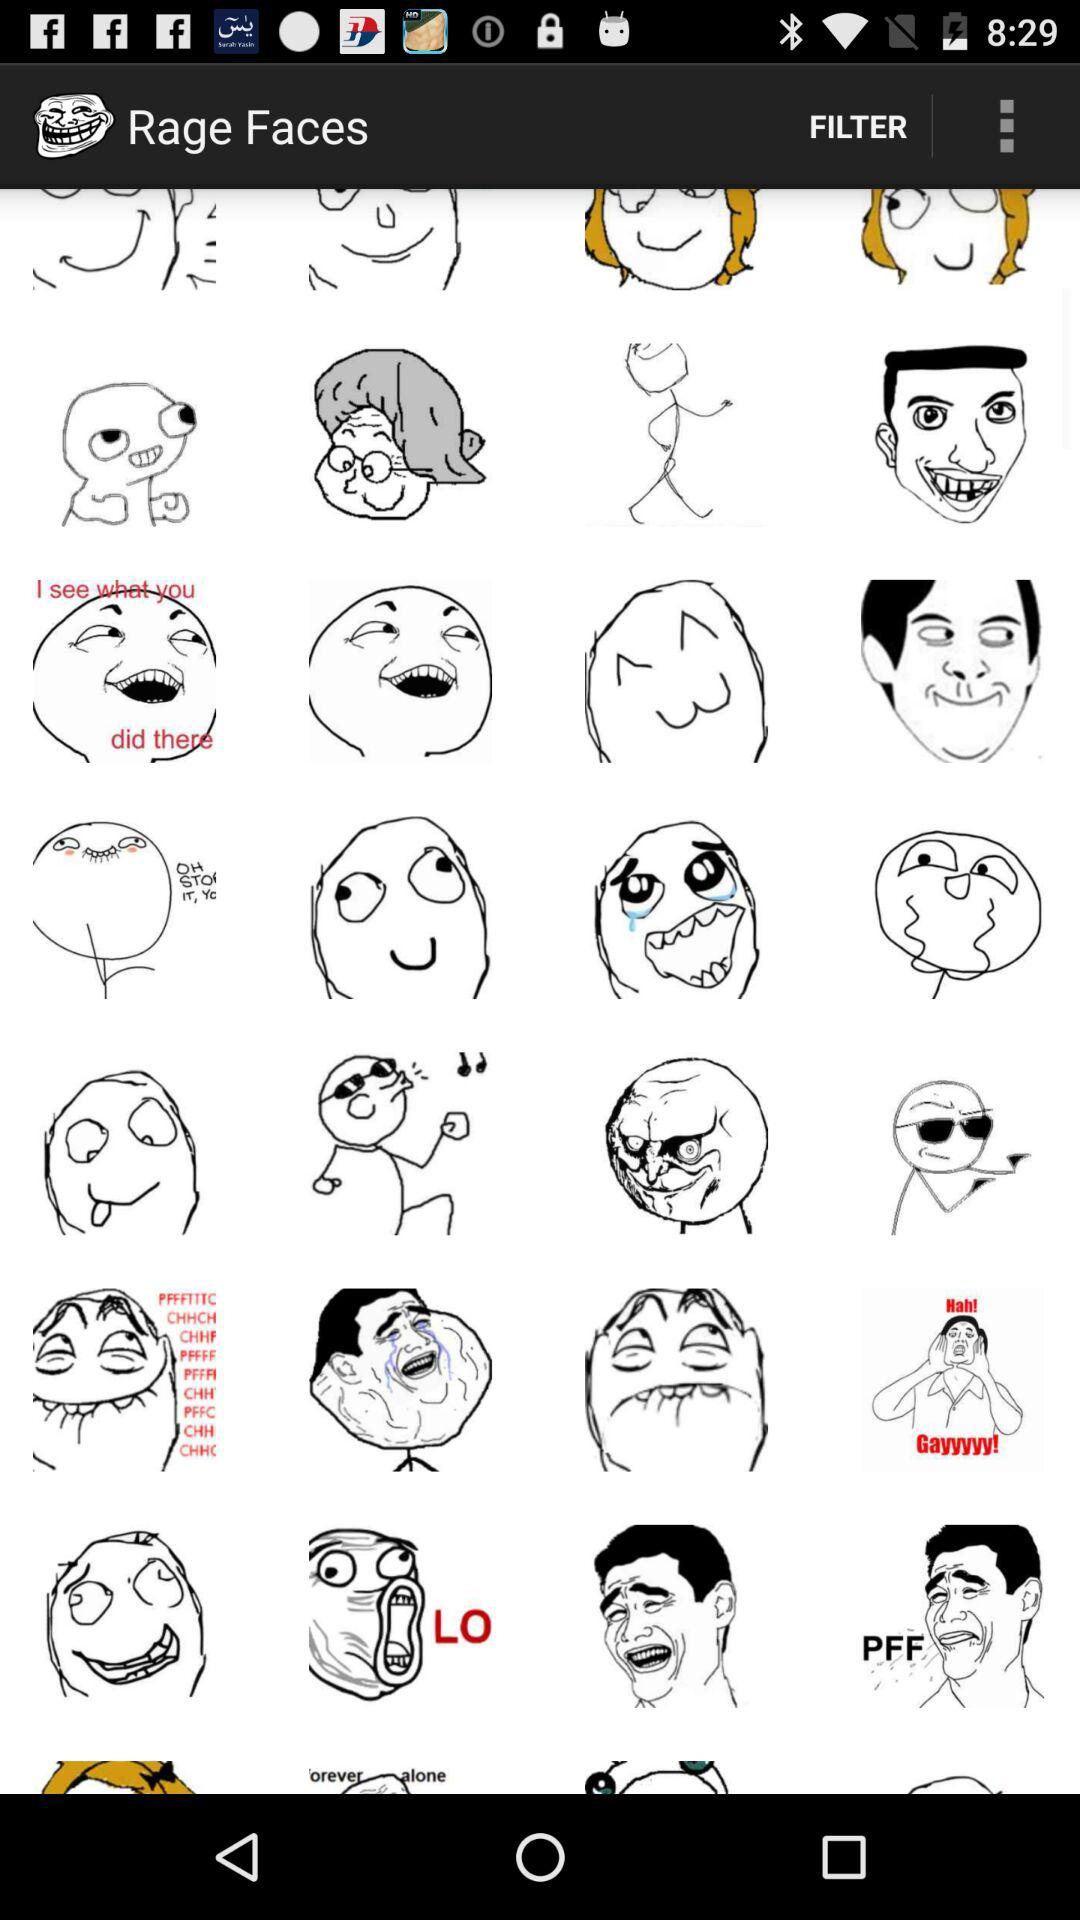What is the application name? The application name is "Rage Faces". 